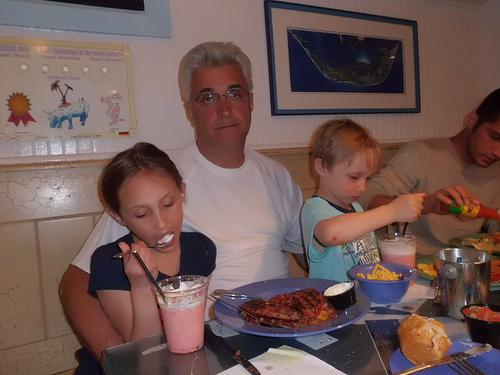Question: where is the food?
Choices:
A. In the frying pan.
B. On the stove.
C. On the table.
D. On the plate.
Answer with the letter. Answer: C Question: what is she eating?
Choices:
A. Ice cream.
B. Apples.
C. Cake.
D. Steak.
Answer with the letter. Answer: A Question: how many people?
Choices:
A. 2.
B. 3.
C. 4.
D. 6.
Answer with the letter. Answer: C Question: why are they there?
Choices:
A. To play.
B. To rest.
C. To run.
D. To eat.
Answer with the letter. Answer: D Question: what are they eating?
Choices:
A. Hamburgers.
B. Pizza.
C. Sushi.
D. Food.
Answer with the letter. Answer: D 